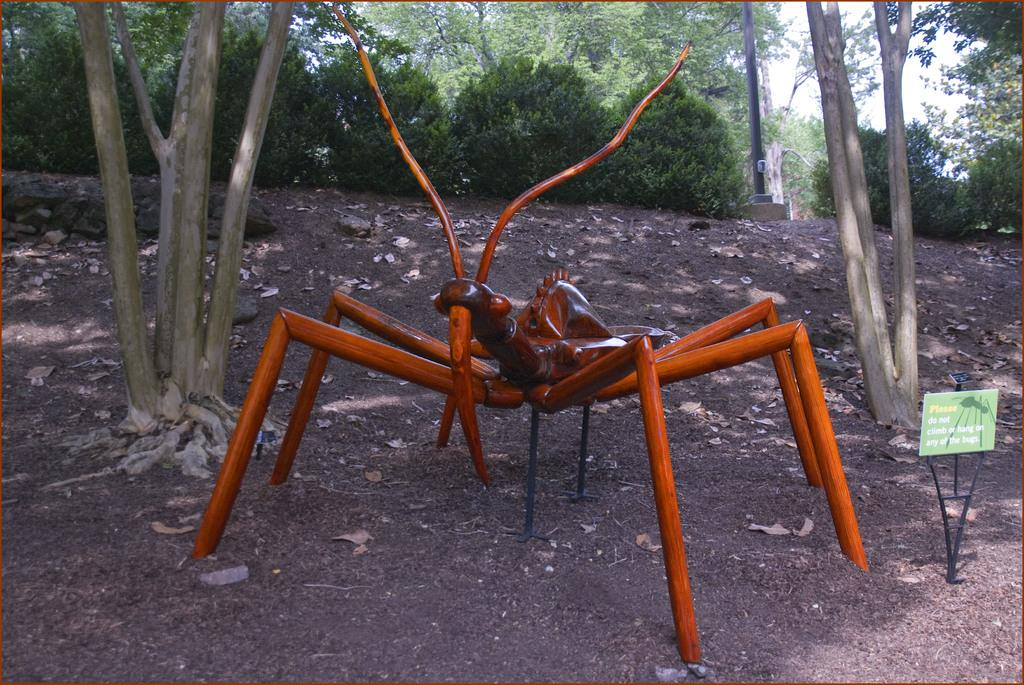What type of statue is present in the image? There is a wooden spider statue in the image. What natural elements can be seen in the image? Trees are visible in the image. What other object can be seen in the image besides the statue and trees? There is a pole in the image. What type of structure is present in the image? There is a board on a stand in the image. What type of ring can be seen on the spider's leg in the image? There is no ring present on the spider's leg in the image, as the statue is made of wood and does not have any rings. 